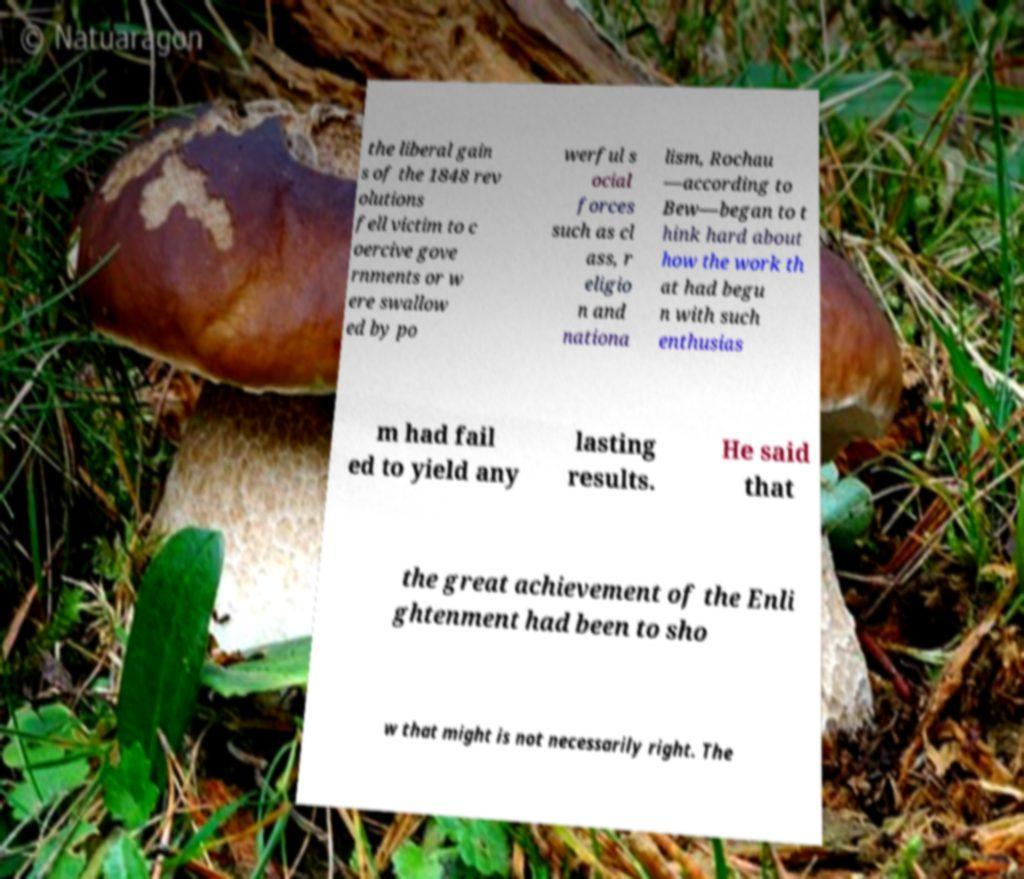Please identify and transcribe the text found in this image. the liberal gain s of the 1848 rev olutions fell victim to c oercive gove rnments or w ere swallow ed by po werful s ocial forces such as cl ass, r eligio n and nationa lism, Rochau —according to Bew—began to t hink hard about how the work th at had begu n with such enthusias m had fail ed to yield any lasting results. He said that the great achievement of the Enli ghtenment had been to sho w that might is not necessarily right. The 